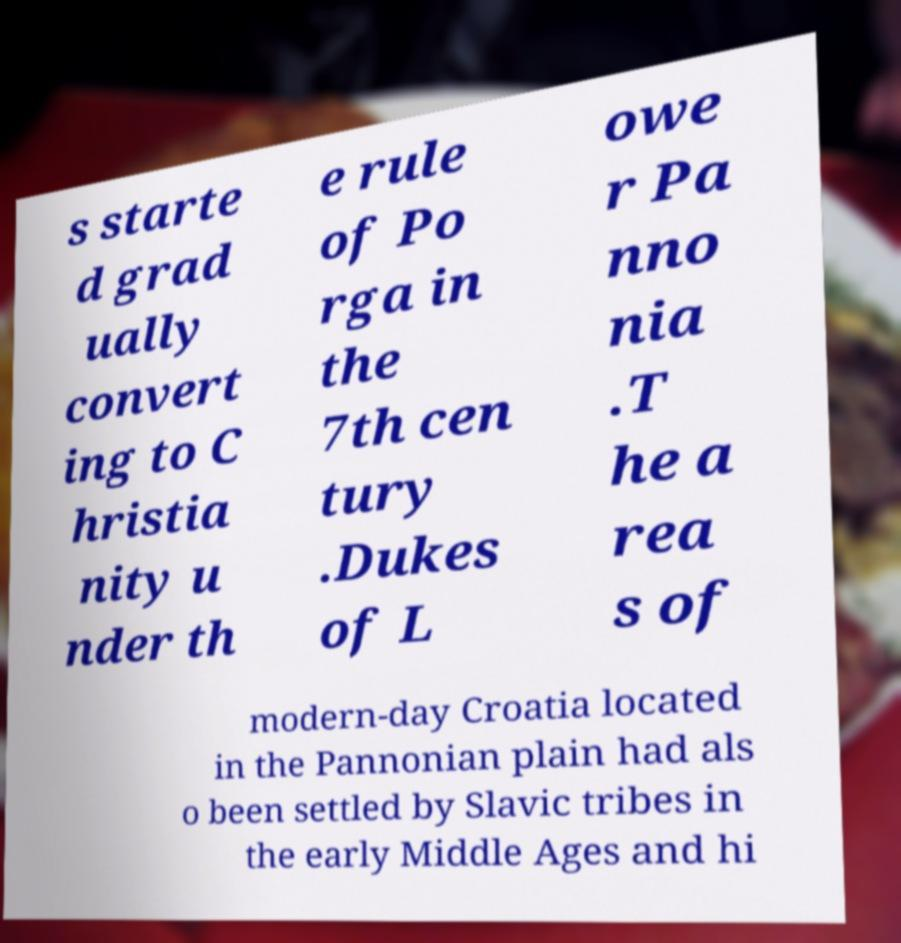Could you extract and type out the text from this image? s starte d grad ually convert ing to C hristia nity u nder th e rule of Po rga in the 7th cen tury .Dukes of L owe r Pa nno nia .T he a rea s of modern-day Croatia located in the Pannonian plain had als o been settled by Slavic tribes in the early Middle Ages and hi 